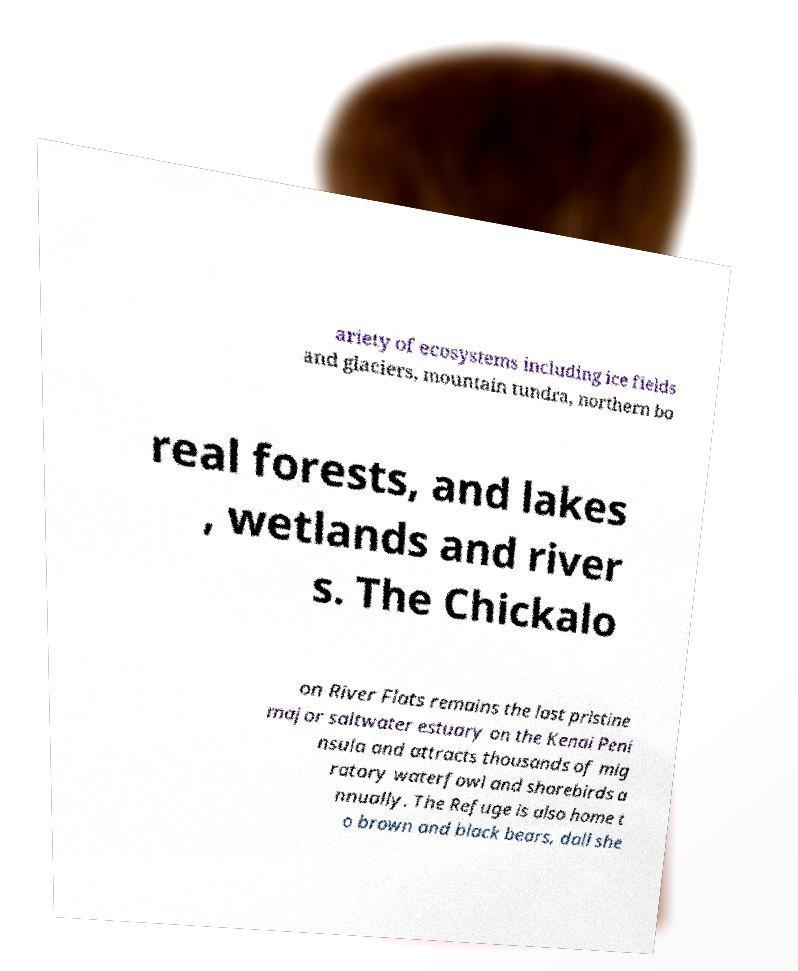Could you assist in decoding the text presented in this image and type it out clearly? ariety of ecosystems including ice fields and glaciers, mountain tundra, northern bo real forests, and lakes , wetlands and river s. The Chickalo on River Flats remains the last pristine major saltwater estuary on the Kenai Peni nsula and attracts thousands of mig ratory waterfowl and shorebirds a nnually. The Refuge is also home t o brown and black bears, dall she 